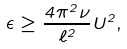Convert formula to latex. <formula><loc_0><loc_0><loc_500><loc_500>\epsilon \geq \frac { 4 \pi ^ { 2 } \nu } { \ell ^ { 2 } } U ^ { 2 } ,</formula> 